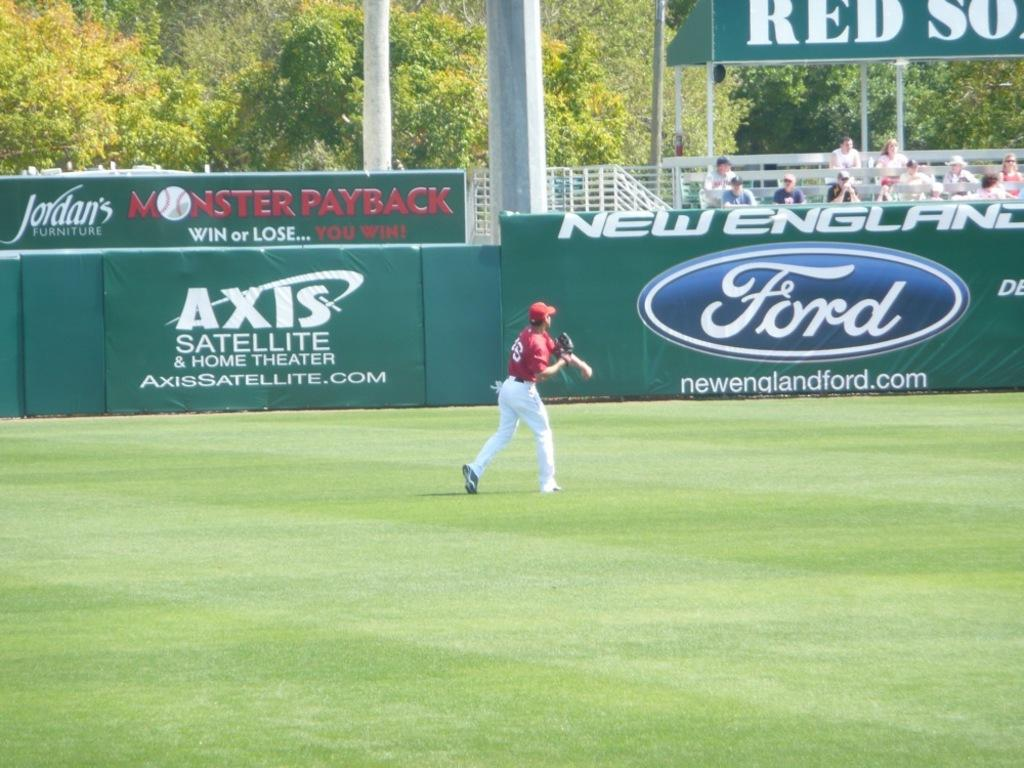Provide a one-sentence caption for the provided image. A baseball player in a red top throws the ball in front of advertising boards for Ford, Axis Satelite and Jordans. 